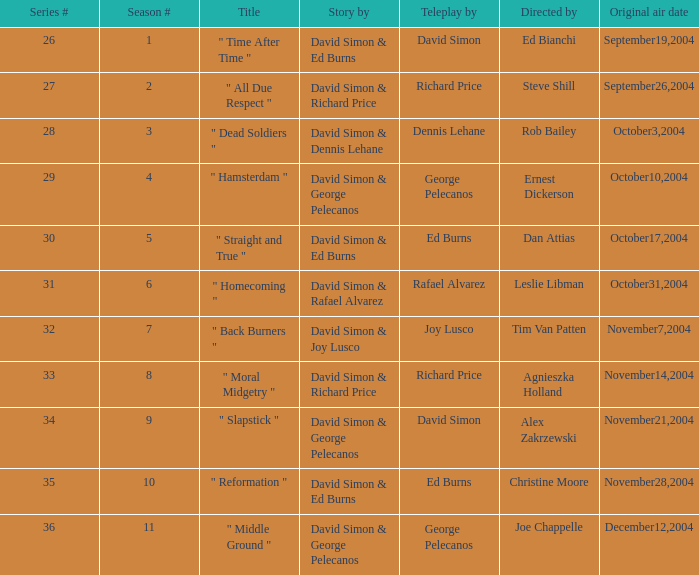Who is the teleplay by when the director is Rob Bailey? Dennis Lehane. 